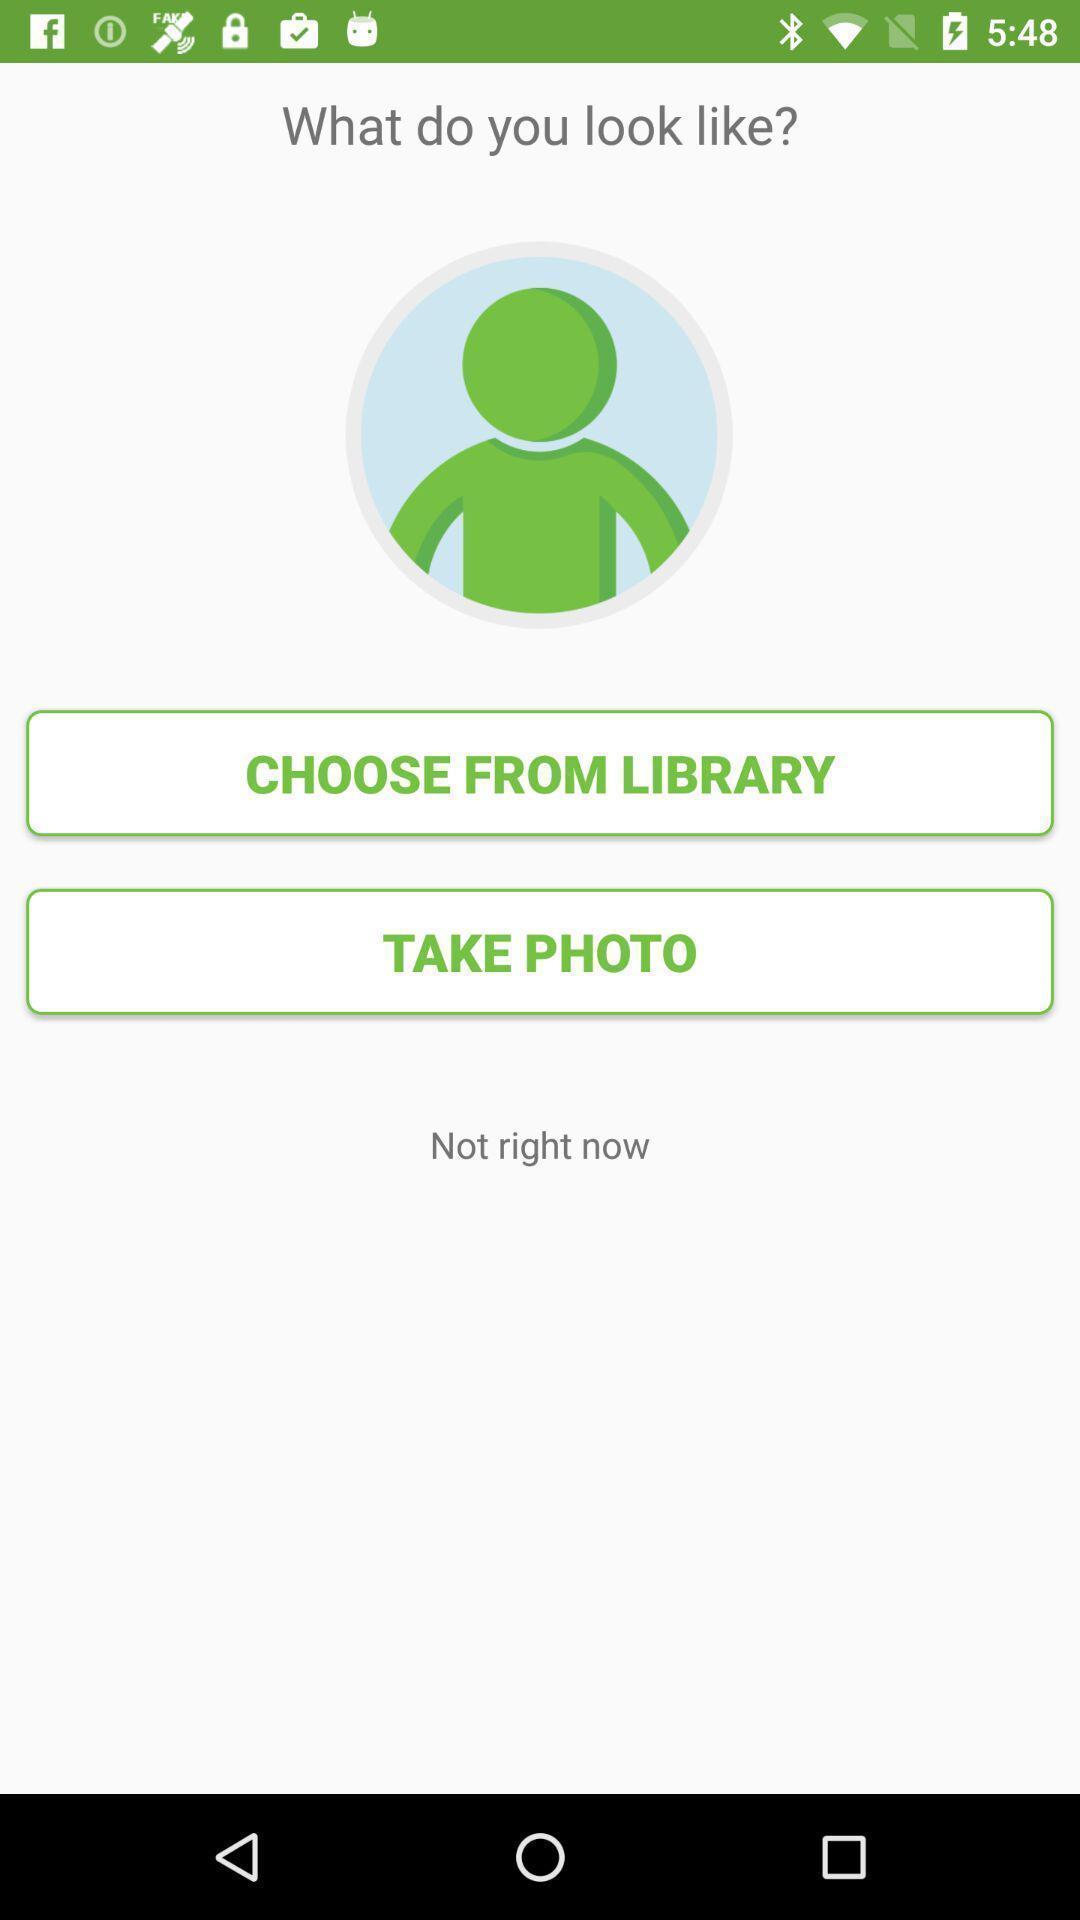Summarize the main components in this picture. Screen showing what do you look like. 